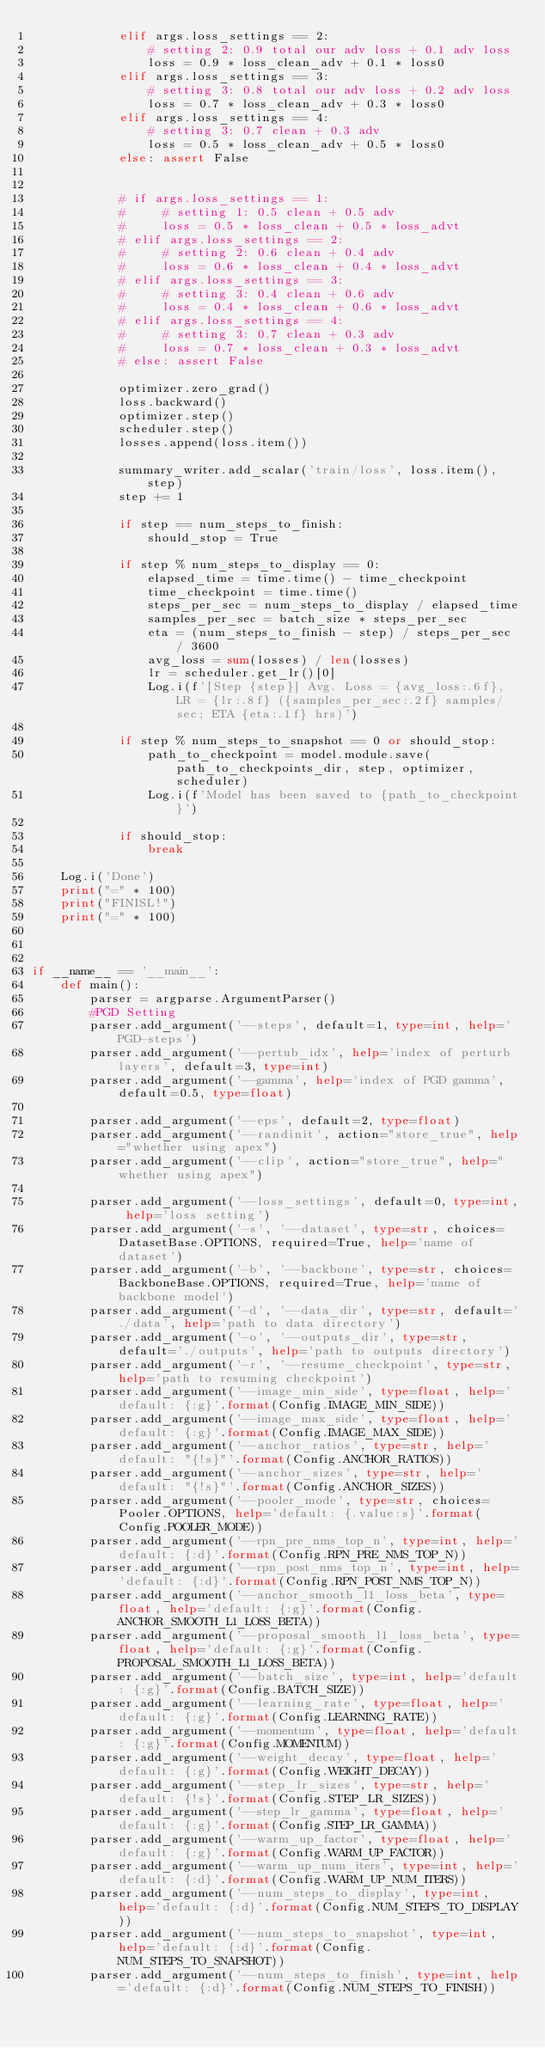<code> <loc_0><loc_0><loc_500><loc_500><_Python_>            elif args.loss_settings == 2:
                # setting 2: 0.9 total our adv loss + 0.1 adv loss
                loss = 0.9 * loss_clean_adv + 0.1 * loss0
            elif args.loss_settings == 3:
                # setting 3: 0.8 total our adv loss + 0.2 adv loss
                loss = 0.7 * loss_clean_adv + 0.3 * loss0
            elif args.loss_settings == 4:
                # setting 3: 0.7 clean + 0.3 adv
                loss = 0.5 * loss_clean_adv + 0.5 * loss0
            else: assert False


            # if args.loss_settings == 1:
            #     # setting 1: 0.5 clean + 0.5 adv
            #     loss = 0.5 * loss_clean + 0.5 * loss_advt
            # elif args.loss_settings == 2:
            #     # setting 2: 0.6 clean + 0.4 adv
            #     loss = 0.6 * loss_clean + 0.4 * loss_advt
            # elif args.loss_settings == 3:
            #     # setting 3: 0.4 clean + 0.6 adv
            #     loss = 0.4 * loss_clean + 0.6 * loss_advt
            # elif args.loss_settings == 4:
            #     # setting 3: 0.7 clean + 0.3 adv
            #     loss = 0.7 * loss_clean + 0.3 * loss_advt
            # else: assert False

            optimizer.zero_grad()
            loss.backward()
            optimizer.step()
            scheduler.step()
            losses.append(loss.item())

            summary_writer.add_scalar('train/loss', loss.item(), step)
            step += 1

            if step == num_steps_to_finish:
                should_stop = True

            if step % num_steps_to_display == 0:
                elapsed_time = time.time() - time_checkpoint
                time_checkpoint = time.time()
                steps_per_sec = num_steps_to_display / elapsed_time
                samples_per_sec = batch_size * steps_per_sec
                eta = (num_steps_to_finish - step) / steps_per_sec / 3600
                avg_loss = sum(losses) / len(losses)
                lr = scheduler.get_lr()[0]
                Log.i(f'[Step {step}] Avg. Loss = {avg_loss:.6f}, LR = {lr:.8f} ({samples_per_sec:.2f} samples/sec; ETA {eta:.1f} hrs)')

            if step % num_steps_to_snapshot == 0 or should_stop:
                path_to_checkpoint = model.module.save(path_to_checkpoints_dir, step, optimizer, scheduler)
                Log.i(f'Model has been saved to {path_to_checkpoint}')

            if should_stop:
                break

    Log.i('Done')
    print("=" * 100)
    print("FINISL!")
    print("=" * 100)



if __name__ == '__main__':
    def main():
        parser = argparse.ArgumentParser()
        #PGD Setting 
        parser.add_argument('--steps', default=1, type=int, help='PGD-steps')
        parser.add_argument('--pertub_idx', help='index of perturb layers', default=3, type=int)
        parser.add_argument('--gamma', help='index of PGD gamma', default=0.5, type=float)
        
        parser.add_argument('--eps', default=2, type=float)
        parser.add_argument('--randinit', action="store_true", help="whether using apex")
        parser.add_argument('--clip', action="store_true", help="whether using apex")

        parser.add_argument('--loss_settings', default=0, type=int, help='loss setting')
        parser.add_argument('-s', '--dataset', type=str, choices=DatasetBase.OPTIONS, required=True, help='name of dataset')
        parser.add_argument('-b', '--backbone', type=str, choices=BackboneBase.OPTIONS, required=True, help='name of backbone model')
        parser.add_argument('-d', '--data_dir', type=str, default='./data', help='path to data directory')
        parser.add_argument('-o', '--outputs_dir', type=str, default='./outputs', help='path to outputs directory')
        parser.add_argument('-r', '--resume_checkpoint', type=str, help='path to resuming checkpoint')
        parser.add_argument('--image_min_side', type=float, help='default: {:g}'.format(Config.IMAGE_MIN_SIDE))
        parser.add_argument('--image_max_side', type=float, help='default: {:g}'.format(Config.IMAGE_MAX_SIDE))
        parser.add_argument('--anchor_ratios', type=str, help='default: "{!s}"'.format(Config.ANCHOR_RATIOS))
        parser.add_argument('--anchor_sizes', type=str, help='default: "{!s}"'.format(Config.ANCHOR_SIZES))
        parser.add_argument('--pooler_mode', type=str, choices=Pooler.OPTIONS, help='default: {.value:s}'.format(Config.POOLER_MODE))
        parser.add_argument('--rpn_pre_nms_top_n', type=int, help='default: {:d}'.format(Config.RPN_PRE_NMS_TOP_N))
        parser.add_argument('--rpn_post_nms_top_n', type=int, help='default: {:d}'.format(Config.RPN_POST_NMS_TOP_N))
        parser.add_argument('--anchor_smooth_l1_loss_beta', type=float, help='default: {:g}'.format(Config.ANCHOR_SMOOTH_L1_LOSS_BETA))
        parser.add_argument('--proposal_smooth_l1_loss_beta', type=float, help='default: {:g}'.format(Config.PROPOSAL_SMOOTH_L1_LOSS_BETA))
        parser.add_argument('--batch_size', type=int, help='default: {:g}'.format(Config.BATCH_SIZE))
        parser.add_argument('--learning_rate', type=float, help='default: {:g}'.format(Config.LEARNING_RATE))
        parser.add_argument('--momentum', type=float, help='default: {:g}'.format(Config.MOMENTUM))
        parser.add_argument('--weight_decay', type=float, help='default: {:g}'.format(Config.WEIGHT_DECAY))
        parser.add_argument('--step_lr_sizes', type=str, help='default: {!s}'.format(Config.STEP_LR_SIZES))
        parser.add_argument('--step_lr_gamma', type=float, help='default: {:g}'.format(Config.STEP_LR_GAMMA))
        parser.add_argument('--warm_up_factor', type=float, help='default: {:g}'.format(Config.WARM_UP_FACTOR))
        parser.add_argument('--warm_up_num_iters', type=int, help='default: {:d}'.format(Config.WARM_UP_NUM_ITERS))
        parser.add_argument('--num_steps_to_display', type=int, help='default: {:d}'.format(Config.NUM_STEPS_TO_DISPLAY))
        parser.add_argument('--num_steps_to_snapshot', type=int, help='default: {:d}'.format(Config.NUM_STEPS_TO_SNAPSHOT))
        parser.add_argument('--num_steps_to_finish', type=int, help='default: {:d}'.format(Config.NUM_STEPS_TO_FINISH))</code> 